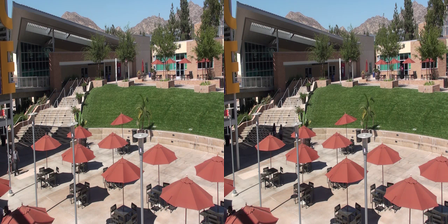Can you tell which of the two images seems more lively and why? The right image appears more lively. This impression might come from several differences: the presence of an extra tree adds to an increased sense of nature, a person walking on the stairs adds a dynamic human element, and a bird flying through the sky introduces additional movement and life. 